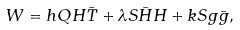<formula> <loc_0><loc_0><loc_500><loc_500>W = h Q H \bar { T } + \lambda S \bar { H } H + k S g \bar { g } ,</formula> 